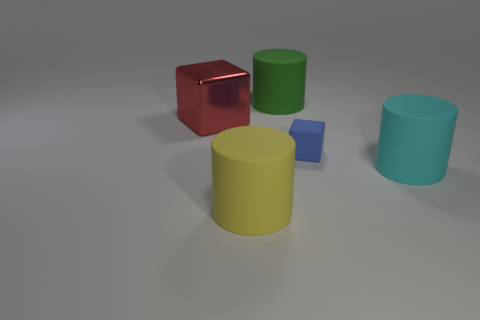Add 2 big red metal objects. How many objects exist? 7 Subtract all cubes. How many objects are left? 3 Subtract all yellow cubes. Subtract all yellow matte cylinders. How many objects are left? 4 Add 3 large matte things. How many large matte things are left? 6 Add 4 big red matte cylinders. How many big red matte cylinders exist? 4 Subtract 0 brown cubes. How many objects are left? 5 